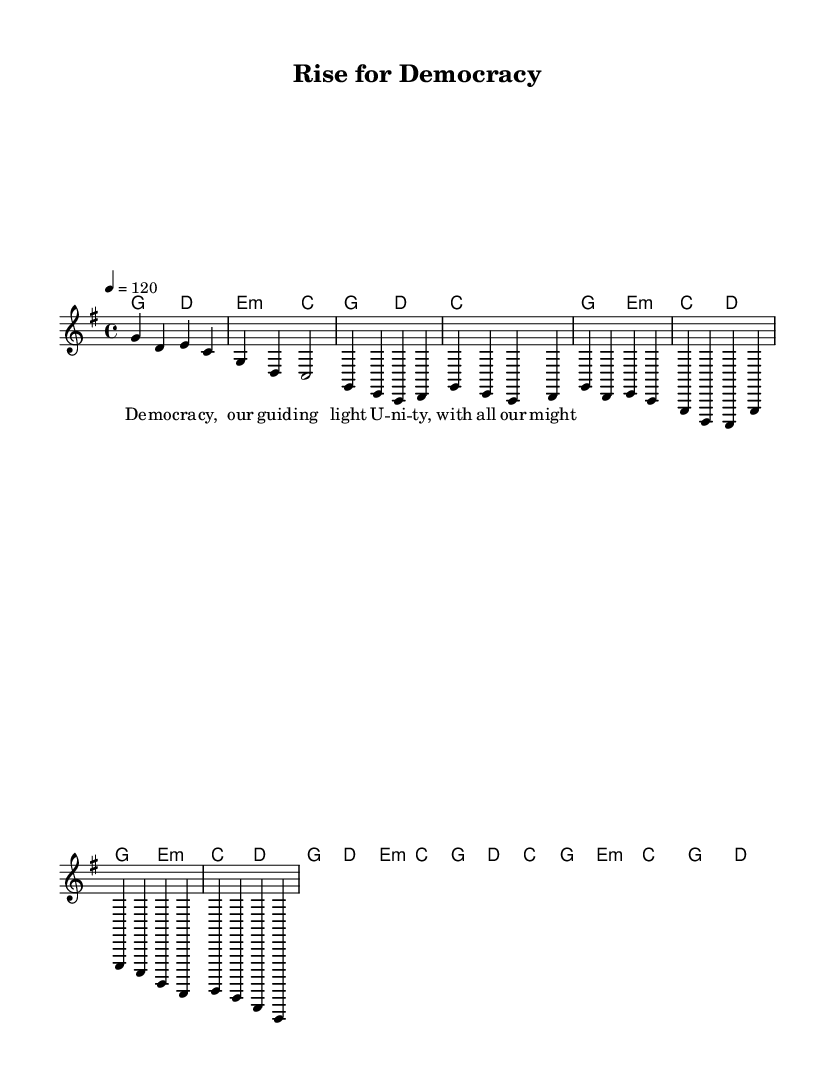What is the key signature of this music? The key signature is G major, which has one sharp (F#). This is identified from the key designation at the beginning of the score, where it states "g \major".
Answer: G major What is the time signature of this music? The time signature is 4/4, indicated at the start of the score right after the key signature. This signifies that there are four beats in each measure, and a quarter note gets one beat.
Answer: 4/4 What is the tempo marking of this piece? The tempo marking is 120 beats per minute, specified in the score as "4 = 120". This tells the performer that the tempo of the music should be played at this pace.
Answer: 120 How many measures are in the intro section? The intro section consists of 2 measures as seen from the notation provided at the beginning of the melody. Each measure contains 4 beats, and the section's beginning is indicated as "Intro".
Answer: 2 What is the name of the song according to the header? The song is titled "Rise for Democracy", which is noted in the header section of the score right at the top. This represents the theme and purpose of the anthem within the sheet music.
Answer: Rise for Democracy What is the chord progression for the chorus? The chord progression for the chorus is G, D, E minor, C, G, D, C, G. This can be deduced by looking at the harmonies section corresponding to the chorus labeled within the structure of the score.
Answer: G, D, E minor, C, G, D, C, G What musical elements are indicative of social change themes in this type of Rock music? The use of anthemic lyrics, strong melodies, and major key signatures play a crucial role in embodying themes of social change. In the provided lyrics and arrangement, the words reflect unity and hope which are common in Rock anthems.
Answer: Anthemic lyrics, strong melodies 